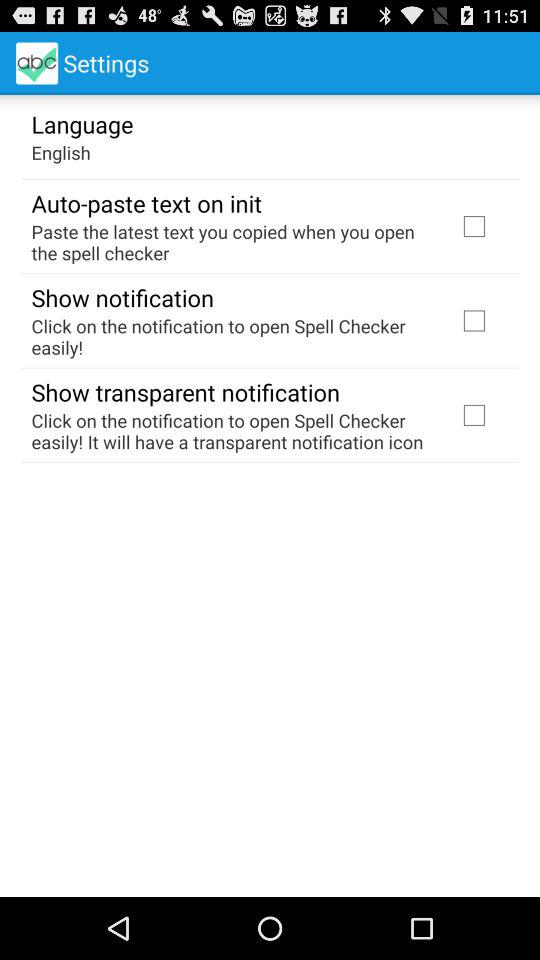What is the status of the show notification? The status is "off". 